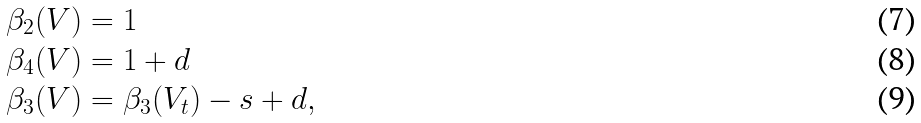Convert formula to latex. <formula><loc_0><loc_0><loc_500><loc_500>\beta _ { 2 } ( V ) & = 1 \\ \beta _ { 4 } ( V ) & = 1 + d \\ \beta _ { 3 } ( V ) & = \beta _ { 3 } ( V _ { t } ) - s + d ,</formula> 